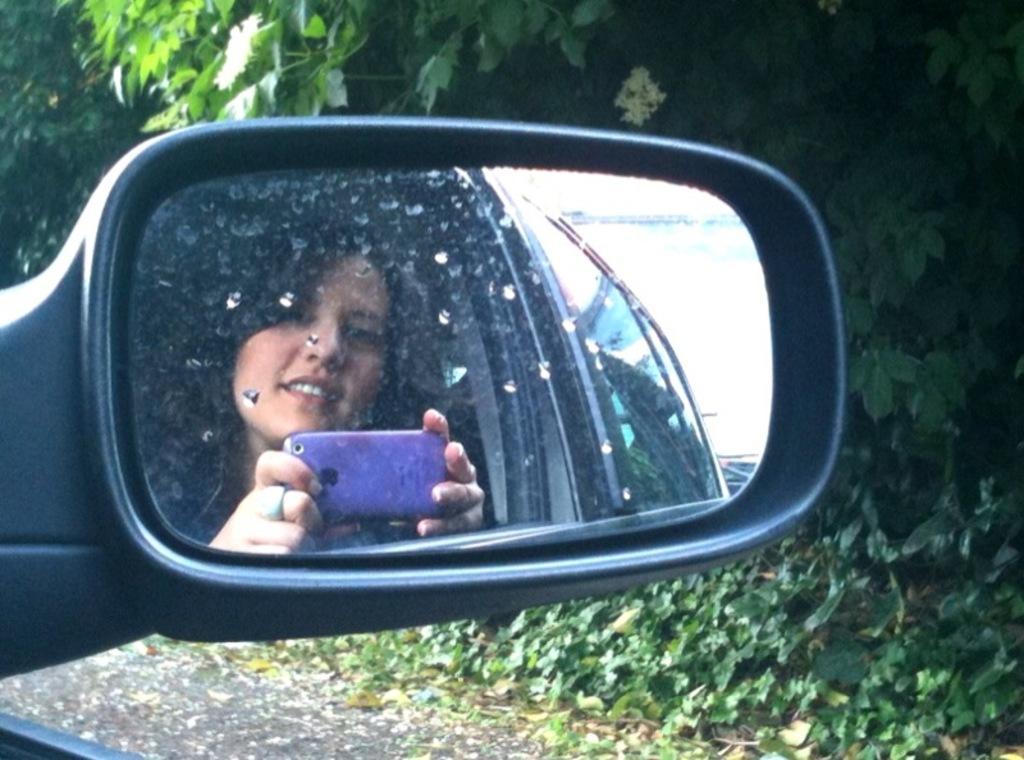How would you summarize this image in a sentence or two? In this picture we can see a woman taking a picture of herself using a mobile phone in the rear mirror of a car. 